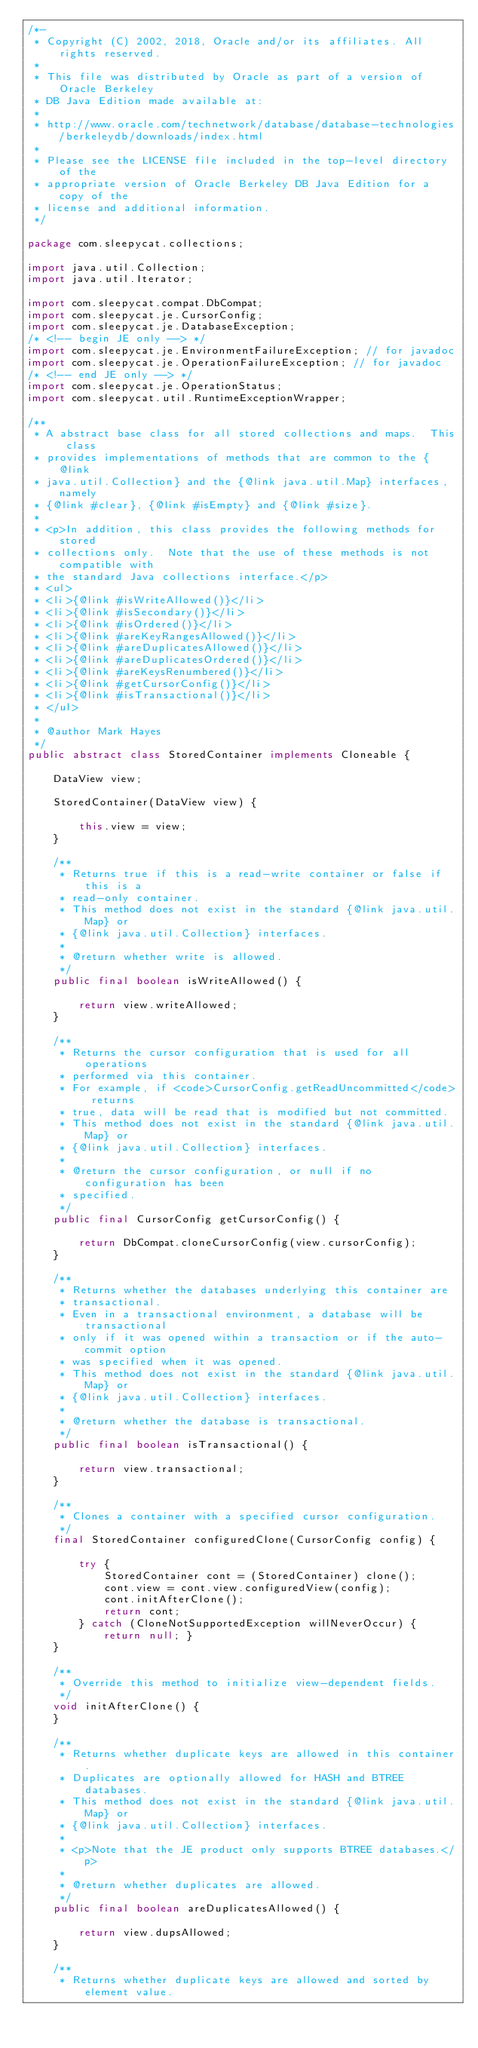<code> <loc_0><loc_0><loc_500><loc_500><_Java_>/*-
 * Copyright (C) 2002, 2018, Oracle and/or its affiliates. All rights reserved.
 *
 * This file was distributed by Oracle as part of a version of Oracle Berkeley
 * DB Java Edition made available at:
 *
 * http://www.oracle.com/technetwork/database/database-technologies/berkeleydb/downloads/index.html
 *
 * Please see the LICENSE file included in the top-level directory of the
 * appropriate version of Oracle Berkeley DB Java Edition for a copy of the
 * license and additional information.
 */

package com.sleepycat.collections;

import java.util.Collection;
import java.util.Iterator;

import com.sleepycat.compat.DbCompat;
import com.sleepycat.je.CursorConfig;
import com.sleepycat.je.DatabaseException;
/* <!-- begin JE only --> */
import com.sleepycat.je.EnvironmentFailureException; // for javadoc
import com.sleepycat.je.OperationFailureException; // for javadoc
/* <!-- end JE only --> */
import com.sleepycat.je.OperationStatus;
import com.sleepycat.util.RuntimeExceptionWrapper;

/**
 * A abstract base class for all stored collections and maps.  This class
 * provides implementations of methods that are common to the {@link
 * java.util.Collection} and the {@link java.util.Map} interfaces, namely
 * {@link #clear}, {@link #isEmpty} and {@link #size}.
 *
 * <p>In addition, this class provides the following methods for stored
 * collections only.  Note that the use of these methods is not compatible with
 * the standard Java collections interface.</p>
 * <ul>
 * <li>{@link #isWriteAllowed()}</li>
 * <li>{@link #isSecondary()}</li>
 * <li>{@link #isOrdered()}</li>
 * <li>{@link #areKeyRangesAllowed()}</li>
 * <li>{@link #areDuplicatesAllowed()}</li>
 * <li>{@link #areDuplicatesOrdered()}</li>
 * <li>{@link #areKeysRenumbered()}</li>
 * <li>{@link #getCursorConfig()}</li>
 * <li>{@link #isTransactional()}</li>
 * </ul>
 *
 * @author Mark Hayes
 */
public abstract class StoredContainer implements Cloneable {

    DataView view;

    StoredContainer(DataView view) {

        this.view = view;
    }

    /**
     * Returns true if this is a read-write container or false if this is a
     * read-only container.
     * This method does not exist in the standard {@link java.util.Map} or
     * {@link java.util.Collection} interfaces.
     *
     * @return whether write is allowed.
     */
    public final boolean isWriteAllowed() {

        return view.writeAllowed;
    }

    /**
     * Returns the cursor configuration that is used for all operations
     * performed via this container.
     * For example, if <code>CursorConfig.getReadUncommitted</code> returns
     * true, data will be read that is modified but not committed.
     * This method does not exist in the standard {@link java.util.Map} or
     * {@link java.util.Collection} interfaces.
     *
     * @return the cursor configuration, or null if no configuration has been
     * specified.
     */
    public final CursorConfig getCursorConfig() {

        return DbCompat.cloneCursorConfig(view.cursorConfig);
    }

    /**
     * Returns whether the databases underlying this container are
     * transactional.
     * Even in a transactional environment, a database will be transactional
     * only if it was opened within a transaction or if the auto-commit option
     * was specified when it was opened.
     * This method does not exist in the standard {@link java.util.Map} or
     * {@link java.util.Collection} interfaces.
     *
     * @return whether the database is transactional.
     */
    public final boolean isTransactional() {

        return view.transactional;
    }

    /**
     * Clones a container with a specified cursor configuration.
     */
    final StoredContainer configuredClone(CursorConfig config) {

        try {
            StoredContainer cont = (StoredContainer) clone();
            cont.view = cont.view.configuredView(config);
            cont.initAfterClone();
            return cont;
        } catch (CloneNotSupportedException willNeverOccur) { return null; }
    }

    /**
     * Override this method to initialize view-dependent fields.
     */
    void initAfterClone() {
    }

    /**
     * Returns whether duplicate keys are allowed in this container.
     * Duplicates are optionally allowed for HASH and BTREE databases.
     * This method does not exist in the standard {@link java.util.Map} or
     * {@link java.util.Collection} interfaces.
     *
     * <p>Note that the JE product only supports BTREE databases.</p>
     *
     * @return whether duplicates are allowed.
     */
    public final boolean areDuplicatesAllowed() {

        return view.dupsAllowed;
    }

    /**
     * Returns whether duplicate keys are allowed and sorted by element value.</code> 